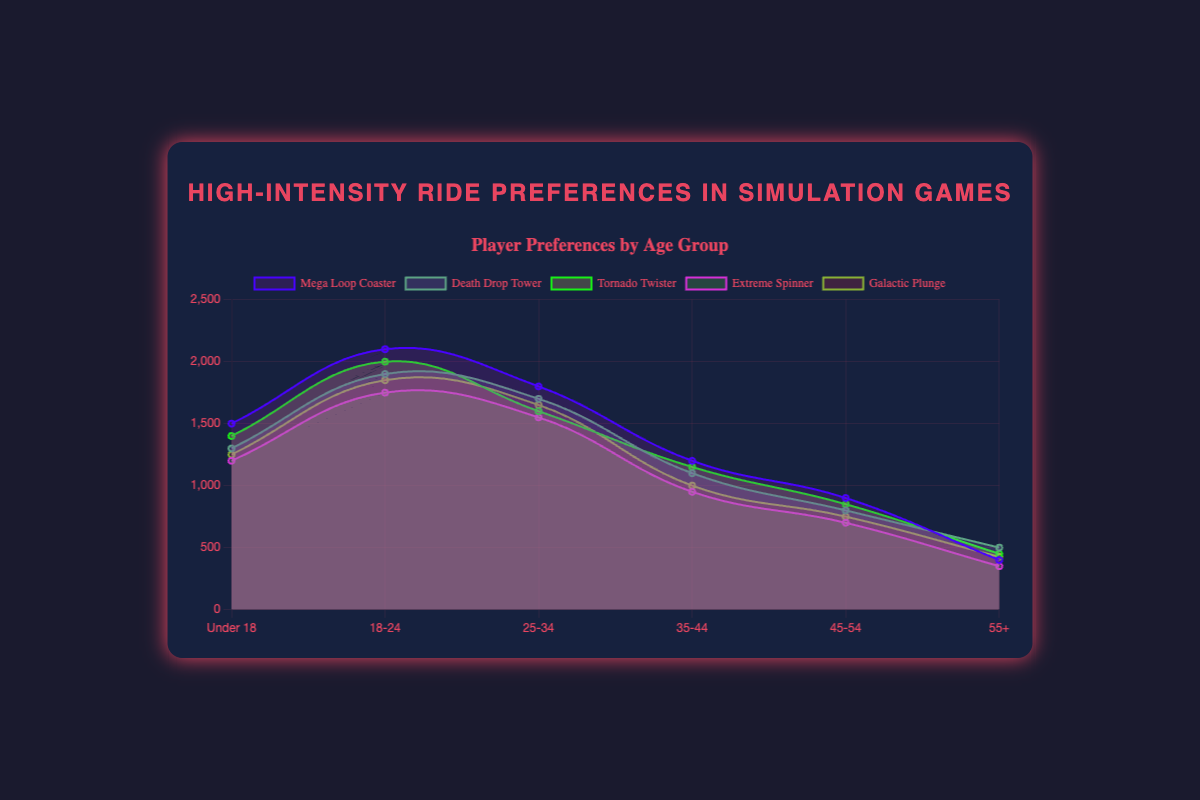What is the title of the chart? The title is usually found at the top of the chart. In this case, it is clearly stated at the top.
Answer: High-Intensity Ride Preferences in Simulation Games Which age group has the highest preference for Mega Loop Coaster? By examining the area for the "Mega Loop Coaster" line, we see that it reaches its highest point at the age group 18-24.
Answer: 18-24 How many age groups are represented in the chart? The x-axis lists the age groups, which we can count. There are six age groups shown: ["Under 18", "18-24", "25-34", "35-44", "45-54", "55+"].
Answer: 6 What is the total preference for Death Drop Tower for players aged 45-54 and 55+? From the y-axis values for "Death Drop Tower", add the preferences of age groups 45-54 (800) and 55+ (500): 800 + 500 = 1300.
Answer: 1300 Which ride has the least preference among the 55+ age group? Look at the values on the y-axis for the 55+ age group and compare for each ride. "Extreme Spinner" has the lowest value, 350.
Answer: Extreme Spinner What is the combined preference for Tornado Twister across all age groups? Summing the values for Tornado Twister: 1400 (Under 18) + 2000 (18-24) + 1600 (25-34) + 1150 (35-44) + 850 (45-54) + 450 (55+) = 7450.
Answer: 7450 How do preferences for Galactic Plunge change with age? Analyze the trend of the "Galactic Plunge" line. It generally decreases from younger to older age groups, starting at 1250 and ending at 425.
Answer: Decreases Which age group shows the highest overall preference for high-intensity rides? Compare the peaks of all rides for each age group. The 18-24 age group generally has the highest values for all rides.
Answer: 18-24 Compare the preference difference for Mega Loop Coaster between the 18-24 and 35-44 age groups. Find the difference: Preference for 18-24 is 2100, and for 35-44 it is 1200. Calculate 2100 - 1200 = 900.
Answer: 900 Which ride shows the most consistent preference across age groups? Look for the ride with the least variance in its values across all age groups. "Galactic Plunge" appears to have a relatively stable set of values compared to others.
Answer: Galactic Plunge 